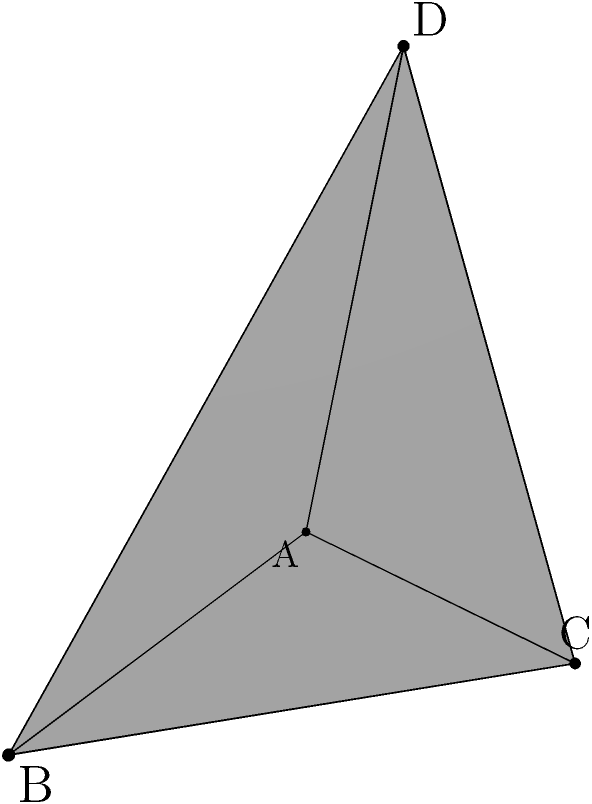Consider a tetrahedron ABCD with vertices A(0,0,0), B(3,0,0), C(1,2,0), and D(1,1,3). Calculate the volume of this tetrahedron. To find the volume of the tetrahedron, we can use the formula:

$$ V = \frac{1}{6}|\text{det}(\vec{AB}, \vec{AC}, \vec{AD})| $$

Where $\vec{AB}$, $\vec{AC}$, and $\vec{AD}$ are vectors representing the edges of the tetrahedron.

Step 1: Calculate the vectors
$\vec{AB} = B - A = (3,0,0) - (0,0,0) = (3,0,0)$
$\vec{AC} = C - A = (1,2,0) - (0,0,0) = (1,2,0)$
$\vec{AD} = D - A = (1,1,3) - (0,0,0) = (1,1,3)$

Step 2: Form the matrix
$$ \begin{vmatrix} 
3 & 1 & 1 \\
0 & 2 & 1 \\
0 & 0 & 3
\end{vmatrix} $$

Step 3: Calculate the determinant
$\text{det} = 3 \cdot (2 \cdot 3 - 0 \cdot 1) - 1 \cdot (0 \cdot 3 - 0 \cdot 1) + 1 \cdot (0 \cdot 0 - 2 \cdot 0) = 18$

Step 4: Apply the volume formula
$$ V = \frac{1}{6}|18| = 3 $$

Therefore, the volume of the tetrahedron is 3 cubic units.
Answer: 3 cubic units 